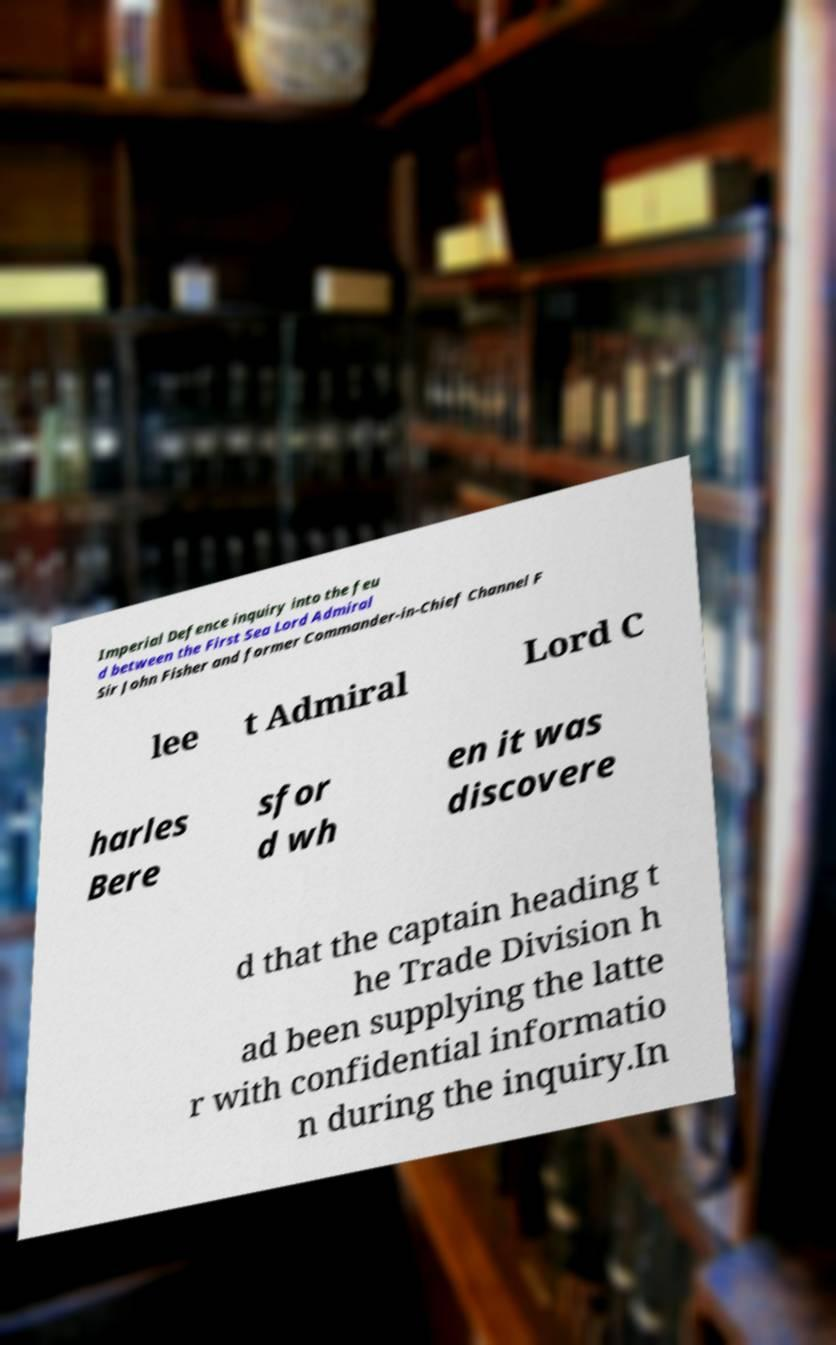Please read and relay the text visible in this image. What does it say? Imperial Defence inquiry into the feu d between the First Sea Lord Admiral Sir John Fisher and former Commander-in-Chief Channel F lee t Admiral Lord C harles Bere sfor d wh en it was discovere d that the captain heading t he Trade Division h ad been supplying the latte r with confidential informatio n during the inquiry.In 